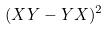<formula> <loc_0><loc_0><loc_500><loc_500>( X Y - Y X ) ^ { 2 }</formula> 